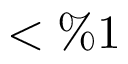Convert formula to latex. <formula><loc_0><loc_0><loc_500><loc_500>< \% 1</formula> 